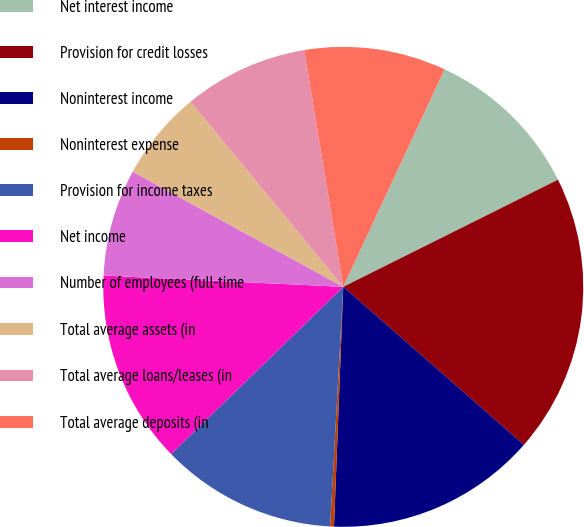Convert chart to OTSL. <chart><loc_0><loc_0><loc_500><loc_500><pie_chart><fcel>Net interest income<fcel>Provision for credit losses<fcel>Noninterest income<fcel>Noninterest expense<fcel>Provision for income taxes<fcel>Net income<fcel>Number of employees (full-time<fcel>Total average assets (in<fcel>Total average loans/leases (in<fcel>Total average deposits (in<nl><fcel>10.7%<fcel>18.81%<fcel>14.18%<fcel>0.26%<fcel>11.86%<fcel>13.02%<fcel>7.22%<fcel>6.06%<fcel>8.38%<fcel>9.54%<nl></chart> 